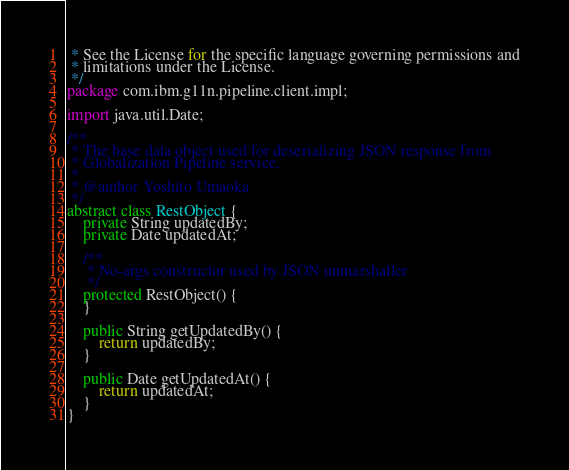Convert code to text. <code><loc_0><loc_0><loc_500><loc_500><_Java_> * See the License for the specific language governing permissions and
 * limitations under the License.
 */
package com.ibm.g11n.pipeline.client.impl;

import java.util.Date;

/**
 * The base data object used for deserializing JSON response from
 * Globalization Pipeline service.
 * 
 * @author Yoshito Umaoka
 */
abstract class RestObject {
    private String updatedBy;
    private Date updatedAt;

    /**
     * No-args constructor used by JSON unmarshaller
     */
    protected RestObject() {
    }

    public String getUpdatedBy() {
        return updatedBy;
    }

    public Date getUpdatedAt() {
        return updatedAt;
    }
}
</code> 